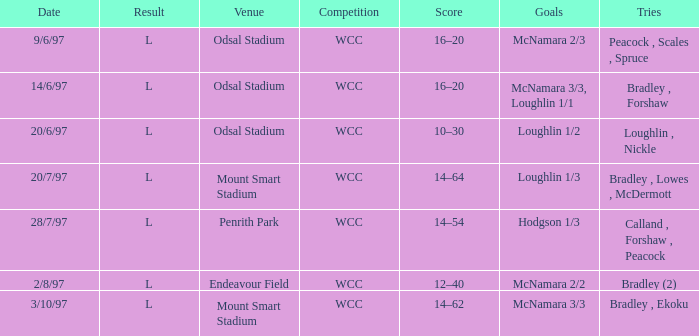What was the score on 20/6/97? 10–30. 